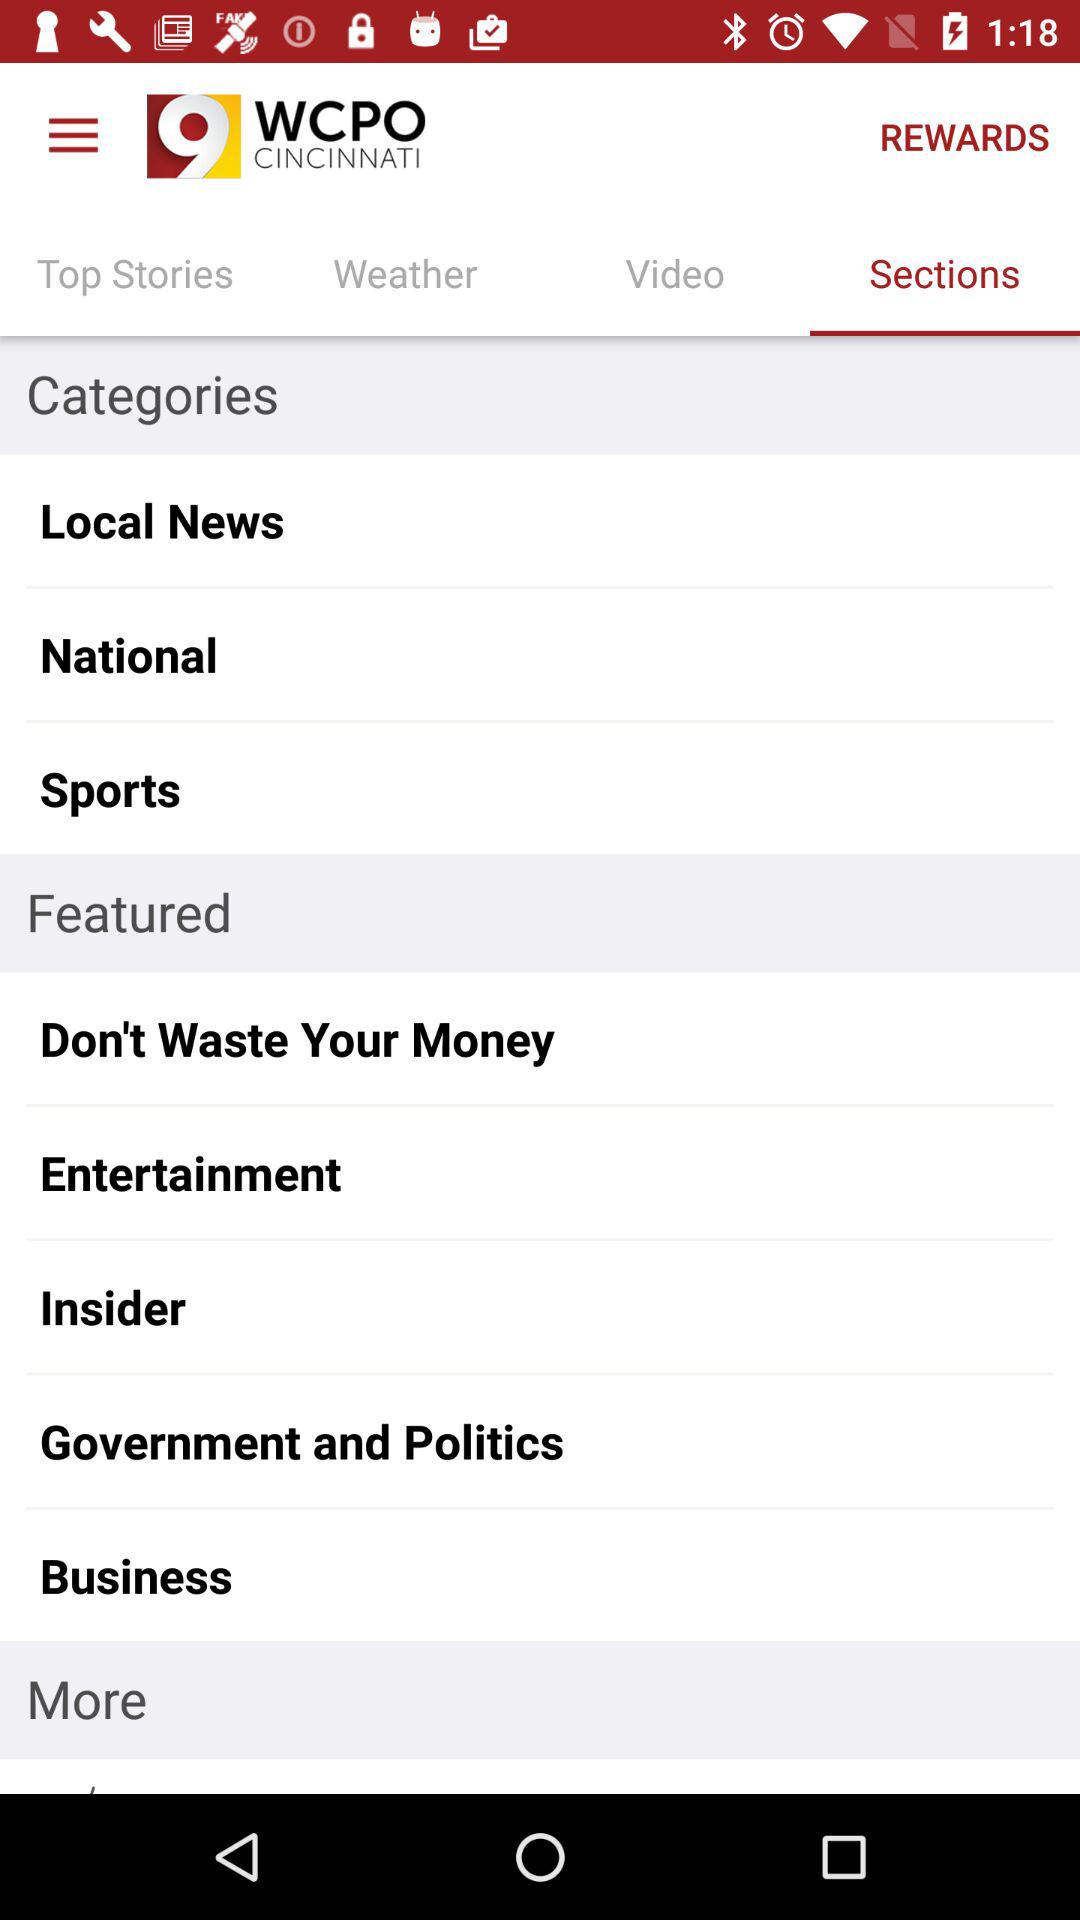When was the application last updated?
When the provided information is insufficient, respond with <no answer>. <no answer> 